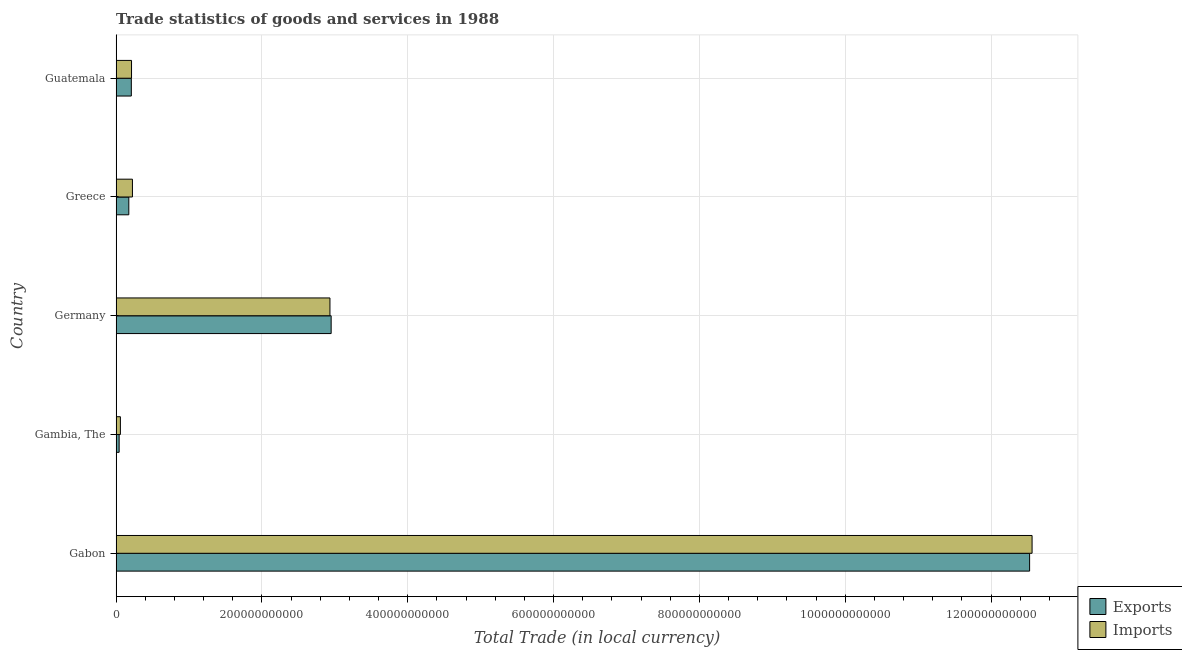How many different coloured bars are there?
Ensure brevity in your answer.  2. How many groups of bars are there?
Your answer should be compact. 5. Are the number of bars on each tick of the Y-axis equal?
Your answer should be very brief. Yes. What is the label of the 1st group of bars from the top?
Offer a terse response. Guatemala. In how many cases, is the number of bars for a given country not equal to the number of legend labels?
Provide a succinct answer. 0. What is the export of goods and services in Gabon?
Provide a short and direct response. 1.25e+12. Across all countries, what is the maximum export of goods and services?
Offer a terse response. 1.25e+12. Across all countries, what is the minimum imports of goods and services?
Provide a short and direct response. 5.84e+09. In which country was the imports of goods and services maximum?
Your answer should be very brief. Gabon. In which country was the export of goods and services minimum?
Keep it short and to the point. Gambia, The. What is the total imports of goods and services in the graph?
Keep it short and to the point. 1.60e+12. What is the difference between the export of goods and services in Gabon and that in Germany?
Your answer should be very brief. 9.58e+11. What is the difference between the export of goods and services in Guatemala and the imports of goods and services in Greece?
Your answer should be very brief. -1.52e+09. What is the average imports of goods and services per country?
Your answer should be very brief. 3.20e+11. What is the difference between the export of goods and services and imports of goods and services in Greece?
Make the answer very short. -4.95e+09. What is the ratio of the imports of goods and services in Gabon to that in Germany?
Your answer should be very brief. 4.28. Is the export of goods and services in Gabon less than that in Germany?
Give a very brief answer. No. What is the difference between the highest and the second highest imports of goods and services?
Ensure brevity in your answer.  9.63e+11. What is the difference between the highest and the lowest imports of goods and services?
Provide a short and direct response. 1.25e+12. Is the sum of the imports of goods and services in Gambia, The and Germany greater than the maximum export of goods and services across all countries?
Offer a terse response. No. What does the 1st bar from the top in Gabon represents?
Your answer should be compact. Imports. What does the 2nd bar from the bottom in Greece represents?
Offer a terse response. Imports. Are all the bars in the graph horizontal?
Your answer should be very brief. Yes. How many countries are there in the graph?
Your answer should be compact. 5. What is the difference between two consecutive major ticks on the X-axis?
Offer a terse response. 2.00e+11. Does the graph contain any zero values?
Make the answer very short. No. Does the graph contain grids?
Make the answer very short. Yes. Where does the legend appear in the graph?
Offer a very short reply. Bottom right. How are the legend labels stacked?
Ensure brevity in your answer.  Vertical. What is the title of the graph?
Keep it short and to the point. Trade statistics of goods and services in 1988. What is the label or title of the X-axis?
Provide a short and direct response. Total Trade (in local currency). What is the label or title of the Y-axis?
Keep it short and to the point. Country. What is the Total Trade (in local currency) of Exports in Gabon?
Provide a succinct answer. 1.25e+12. What is the Total Trade (in local currency) in Imports in Gabon?
Provide a succinct answer. 1.26e+12. What is the Total Trade (in local currency) of Exports in Gambia, The?
Provide a succinct answer. 4.13e+09. What is the Total Trade (in local currency) in Imports in Gambia, The?
Ensure brevity in your answer.  5.84e+09. What is the Total Trade (in local currency) of Exports in Germany?
Offer a very short reply. 2.95e+11. What is the Total Trade (in local currency) in Imports in Germany?
Ensure brevity in your answer.  2.93e+11. What is the Total Trade (in local currency) of Exports in Greece?
Ensure brevity in your answer.  1.74e+1. What is the Total Trade (in local currency) in Imports in Greece?
Offer a terse response. 2.24e+1. What is the Total Trade (in local currency) in Exports in Guatemala?
Keep it short and to the point. 2.08e+1. What is the Total Trade (in local currency) in Imports in Guatemala?
Offer a terse response. 2.11e+1. Across all countries, what is the maximum Total Trade (in local currency) in Exports?
Provide a short and direct response. 1.25e+12. Across all countries, what is the maximum Total Trade (in local currency) in Imports?
Your answer should be compact. 1.26e+12. Across all countries, what is the minimum Total Trade (in local currency) in Exports?
Your answer should be very brief. 4.13e+09. Across all countries, what is the minimum Total Trade (in local currency) of Imports?
Offer a terse response. 5.84e+09. What is the total Total Trade (in local currency) in Exports in the graph?
Your response must be concise. 1.59e+12. What is the total Total Trade (in local currency) of Imports in the graph?
Give a very brief answer. 1.60e+12. What is the difference between the Total Trade (in local currency) of Exports in Gabon and that in Gambia, The?
Make the answer very short. 1.25e+12. What is the difference between the Total Trade (in local currency) of Imports in Gabon and that in Gambia, The?
Your response must be concise. 1.25e+12. What is the difference between the Total Trade (in local currency) of Exports in Gabon and that in Germany?
Offer a very short reply. 9.58e+11. What is the difference between the Total Trade (in local currency) in Imports in Gabon and that in Germany?
Keep it short and to the point. 9.63e+11. What is the difference between the Total Trade (in local currency) in Exports in Gabon and that in Greece?
Your answer should be compact. 1.24e+12. What is the difference between the Total Trade (in local currency) in Imports in Gabon and that in Greece?
Keep it short and to the point. 1.23e+12. What is the difference between the Total Trade (in local currency) in Exports in Gabon and that in Guatemala?
Make the answer very short. 1.23e+12. What is the difference between the Total Trade (in local currency) in Imports in Gabon and that in Guatemala?
Your response must be concise. 1.24e+12. What is the difference between the Total Trade (in local currency) in Exports in Gambia, The and that in Germany?
Give a very brief answer. -2.91e+11. What is the difference between the Total Trade (in local currency) in Imports in Gambia, The and that in Germany?
Provide a succinct answer. -2.87e+11. What is the difference between the Total Trade (in local currency) of Exports in Gambia, The and that in Greece?
Your answer should be very brief. -1.33e+1. What is the difference between the Total Trade (in local currency) in Imports in Gambia, The and that in Greece?
Keep it short and to the point. -1.65e+1. What is the difference between the Total Trade (in local currency) in Exports in Gambia, The and that in Guatemala?
Offer a very short reply. -1.67e+1. What is the difference between the Total Trade (in local currency) in Imports in Gambia, The and that in Guatemala?
Your response must be concise. -1.53e+1. What is the difference between the Total Trade (in local currency) in Exports in Germany and that in Greece?
Offer a terse response. 2.77e+11. What is the difference between the Total Trade (in local currency) of Imports in Germany and that in Greece?
Your answer should be very brief. 2.71e+11. What is the difference between the Total Trade (in local currency) in Exports in Germany and that in Guatemala?
Your response must be concise. 2.74e+11. What is the difference between the Total Trade (in local currency) in Imports in Germany and that in Guatemala?
Your response must be concise. 2.72e+11. What is the difference between the Total Trade (in local currency) of Exports in Greece and that in Guatemala?
Offer a very short reply. -3.43e+09. What is the difference between the Total Trade (in local currency) of Imports in Greece and that in Guatemala?
Provide a short and direct response. 1.22e+09. What is the difference between the Total Trade (in local currency) in Exports in Gabon and the Total Trade (in local currency) in Imports in Gambia, The?
Your answer should be very brief. 1.25e+12. What is the difference between the Total Trade (in local currency) in Exports in Gabon and the Total Trade (in local currency) in Imports in Germany?
Provide a succinct answer. 9.60e+11. What is the difference between the Total Trade (in local currency) of Exports in Gabon and the Total Trade (in local currency) of Imports in Greece?
Provide a succinct answer. 1.23e+12. What is the difference between the Total Trade (in local currency) in Exports in Gabon and the Total Trade (in local currency) in Imports in Guatemala?
Offer a terse response. 1.23e+12. What is the difference between the Total Trade (in local currency) of Exports in Gambia, The and the Total Trade (in local currency) of Imports in Germany?
Give a very brief answer. -2.89e+11. What is the difference between the Total Trade (in local currency) in Exports in Gambia, The and the Total Trade (in local currency) in Imports in Greece?
Offer a very short reply. -1.82e+1. What is the difference between the Total Trade (in local currency) in Exports in Gambia, The and the Total Trade (in local currency) in Imports in Guatemala?
Offer a very short reply. -1.70e+1. What is the difference between the Total Trade (in local currency) of Exports in Germany and the Total Trade (in local currency) of Imports in Greece?
Your answer should be very brief. 2.73e+11. What is the difference between the Total Trade (in local currency) of Exports in Germany and the Total Trade (in local currency) of Imports in Guatemala?
Offer a very short reply. 2.74e+11. What is the difference between the Total Trade (in local currency) of Exports in Greece and the Total Trade (in local currency) of Imports in Guatemala?
Offer a terse response. -3.73e+09. What is the average Total Trade (in local currency) in Exports per country?
Your answer should be very brief. 3.18e+11. What is the average Total Trade (in local currency) of Imports per country?
Your response must be concise. 3.20e+11. What is the difference between the Total Trade (in local currency) in Exports and Total Trade (in local currency) in Imports in Gabon?
Give a very brief answer. -3.40e+09. What is the difference between the Total Trade (in local currency) in Exports and Total Trade (in local currency) in Imports in Gambia, The?
Ensure brevity in your answer.  -1.72e+09. What is the difference between the Total Trade (in local currency) of Exports and Total Trade (in local currency) of Imports in Germany?
Give a very brief answer. 1.65e+09. What is the difference between the Total Trade (in local currency) in Exports and Total Trade (in local currency) in Imports in Greece?
Provide a succinct answer. -4.95e+09. What is the difference between the Total Trade (in local currency) in Exports and Total Trade (in local currency) in Imports in Guatemala?
Ensure brevity in your answer.  -2.96e+08. What is the ratio of the Total Trade (in local currency) in Exports in Gabon to that in Gambia, The?
Offer a very short reply. 303.47. What is the ratio of the Total Trade (in local currency) in Imports in Gabon to that in Gambia, The?
Ensure brevity in your answer.  214.95. What is the ratio of the Total Trade (in local currency) in Exports in Gabon to that in Germany?
Your answer should be very brief. 4.25. What is the ratio of the Total Trade (in local currency) in Imports in Gabon to that in Germany?
Your answer should be very brief. 4.28. What is the ratio of the Total Trade (in local currency) of Exports in Gabon to that in Greece?
Your answer should be compact. 72. What is the ratio of the Total Trade (in local currency) of Imports in Gabon to that in Greece?
Your answer should be very brief. 56.19. What is the ratio of the Total Trade (in local currency) of Exports in Gabon to that in Guatemala?
Your answer should be very brief. 60.13. What is the ratio of the Total Trade (in local currency) in Imports in Gabon to that in Guatemala?
Your answer should be compact. 59.45. What is the ratio of the Total Trade (in local currency) of Exports in Gambia, The to that in Germany?
Your answer should be very brief. 0.01. What is the ratio of the Total Trade (in local currency) of Imports in Gambia, The to that in Germany?
Your answer should be compact. 0.02. What is the ratio of the Total Trade (in local currency) of Exports in Gambia, The to that in Greece?
Your answer should be compact. 0.24. What is the ratio of the Total Trade (in local currency) in Imports in Gambia, The to that in Greece?
Give a very brief answer. 0.26. What is the ratio of the Total Trade (in local currency) of Exports in Gambia, The to that in Guatemala?
Offer a terse response. 0.2. What is the ratio of the Total Trade (in local currency) in Imports in Gambia, The to that in Guatemala?
Provide a short and direct response. 0.28. What is the ratio of the Total Trade (in local currency) in Exports in Germany to that in Greece?
Offer a very short reply. 16.95. What is the ratio of the Total Trade (in local currency) in Imports in Germany to that in Greece?
Your answer should be compact. 13.12. What is the ratio of the Total Trade (in local currency) of Exports in Germany to that in Guatemala?
Ensure brevity in your answer.  14.15. What is the ratio of the Total Trade (in local currency) in Imports in Germany to that in Guatemala?
Your response must be concise. 13.88. What is the ratio of the Total Trade (in local currency) in Exports in Greece to that in Guatemala?
Offer a very short reply. 0.84. What is the ratio of the Total Trade (in local currency) of Imports in Greece to that in Guatemala?
Your answer should be compact. 1.06. What is the difference between the highest and the second highest Total Trade (in local currency) of Exports?
Keep it short and to the point. 9.58e+11. What is the difference between the highest and the second highest Total Trade (in local currency) in Imports?
Offer a very short reply. 9.63e+11. What is the difference between the highest and the lowest Total Trade (in local currency) in Exports?
Make the answer very short. 1.25e+12. What is the difference between the highest and the lowest Total Trade (in local currency) in Imports?
Make the answer very short. 1.25e+12. 